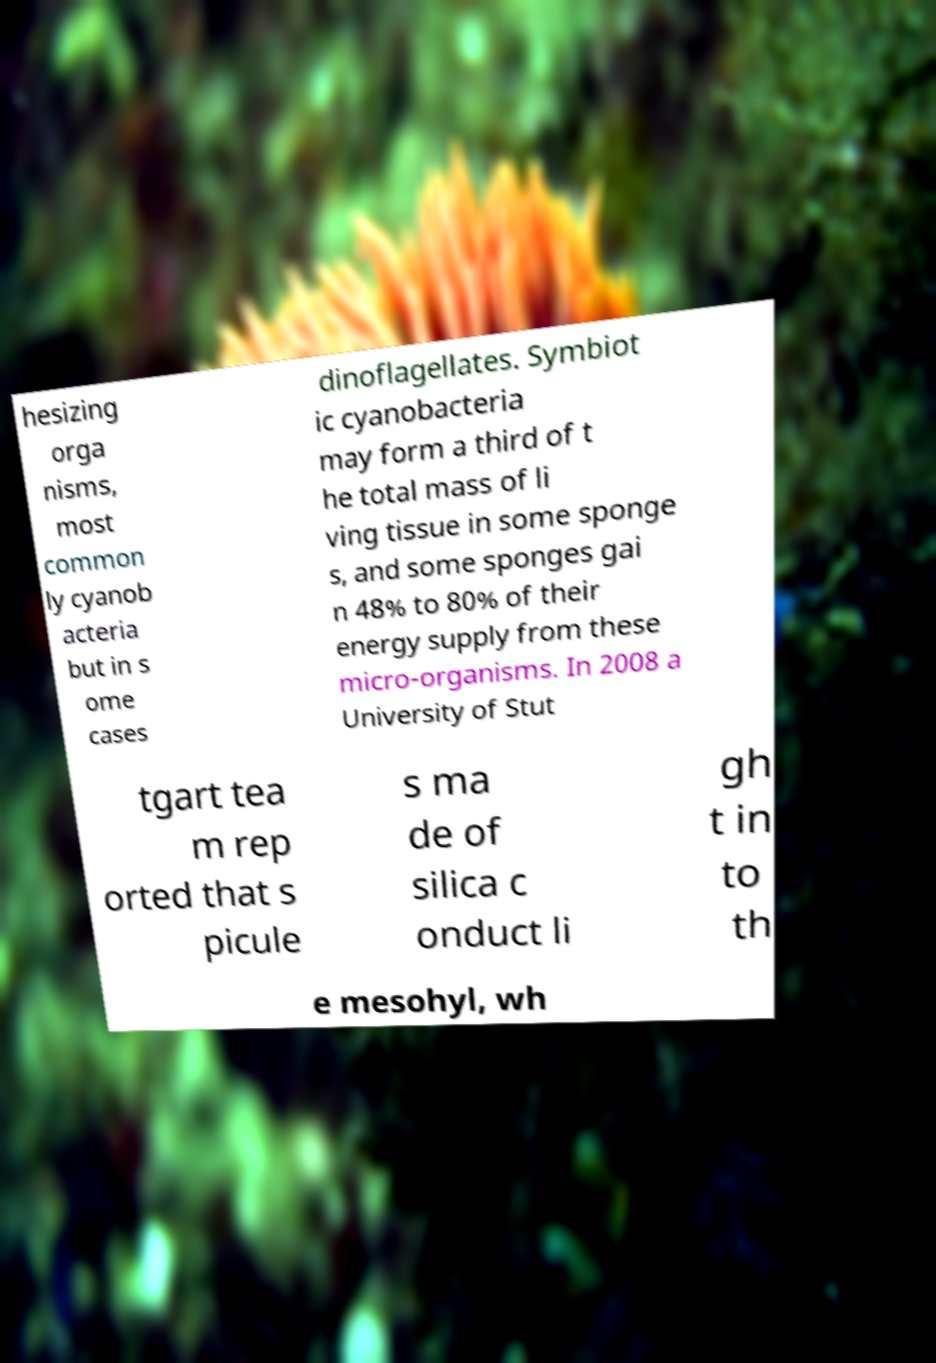Could you extract and type out the text from this image? hesizing orga nisms, most common ly cyanob acteria but in s ome cases dinoflagellates. Symbiot ic cyanobacteria may form a third of t he total mass of li ving tissue in some sponge s, and some sponges gai n 48% to 80% of their energy supply from these micro-organisms. In 2008 a University of Stut tgart tea m rep orted that s picule s ma de of silica c onduct li gh t in to th e mesohyl, wh 